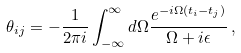<formula> <loc_0><loc_0><loc_500><loc_500>\theta _ { i j } = - \frac { 1 } { 2 \pi i } \int _ { - \infty } ^ { \infty } d \Omega \frac { e ^ { - i \Omega ( t _ { i } - t _ { j } ) } } { \Omega + i \epsilon } \, ,</formula> 